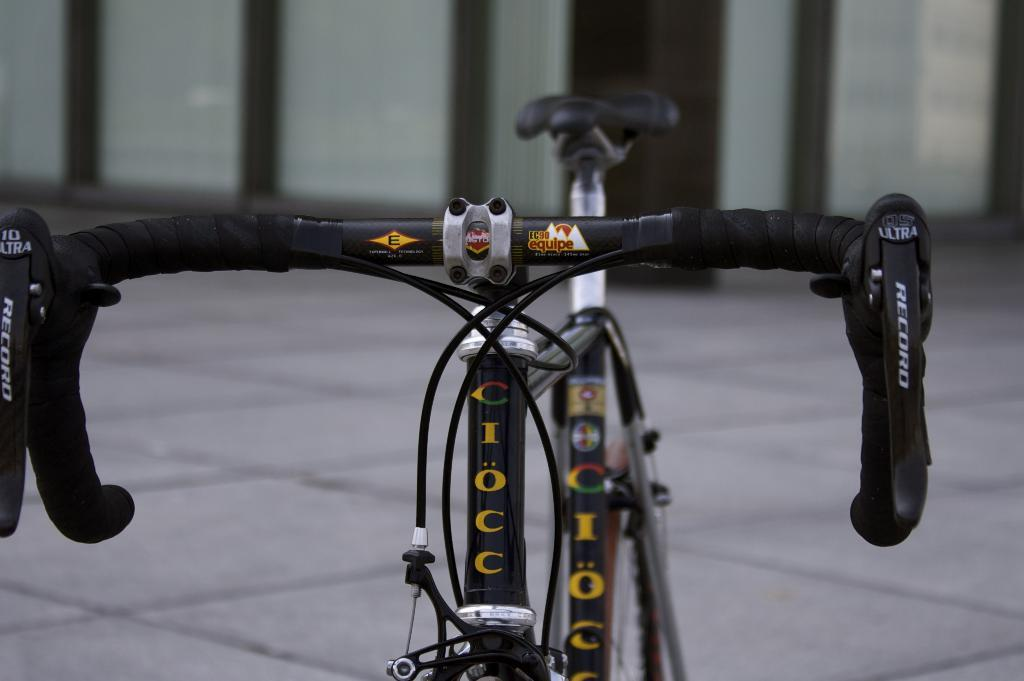What is the main subject in the middle of the image? There is a bicycle in the middle of the image. What can be seen in the background of the image? There is a wall in the background of the image. What type of coast can be seen in the image? There is no coast visible in the image; it features a bicycle and a wall in the background. 